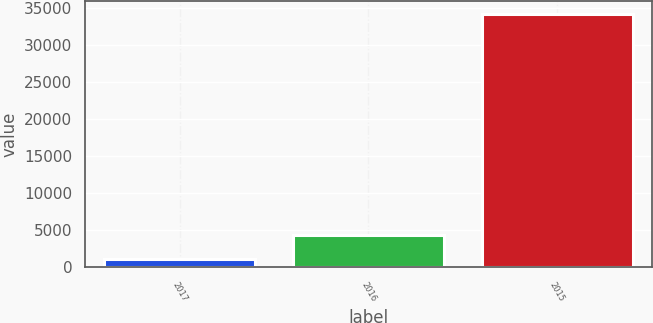Convert chart to OTSL. <chart><loc_0><loc_0><loc_500><loc_500><bar_chart><fcel>2017<fcel>2016<fcel>2015<nl><fcel>1063<fcel>4379.3<fcel>34226<nl></chart> 